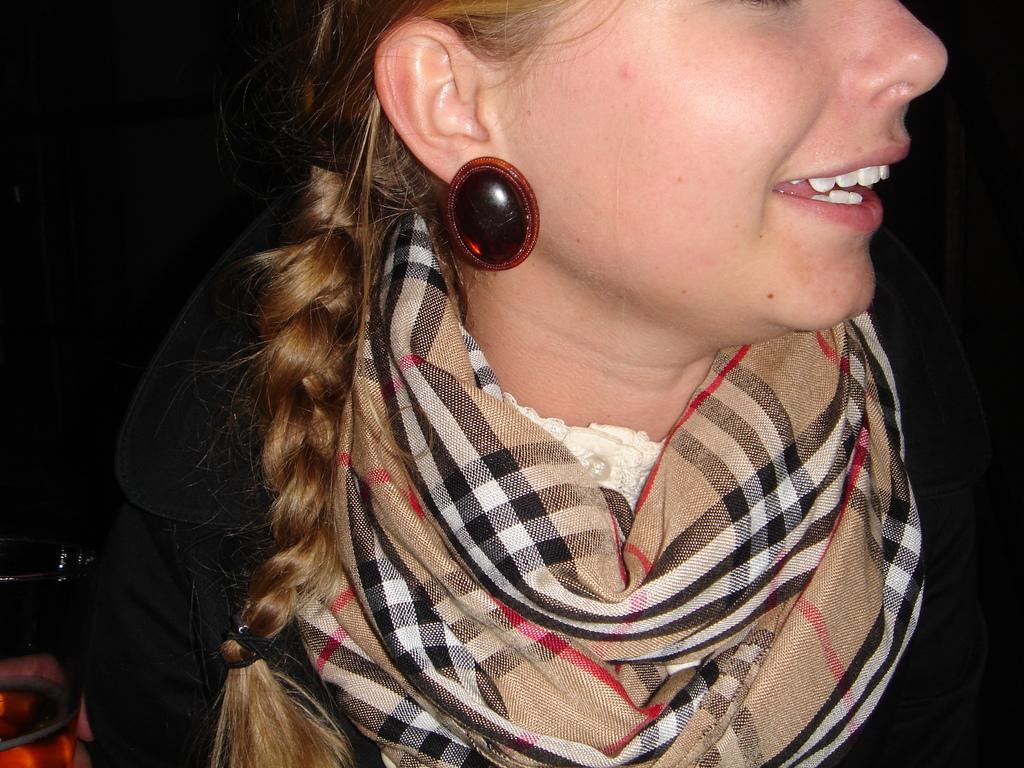Who or what is the main subject of the image? There is a person in the image. What is the person wearing around their neck? The person is wearing a cream and black color scarf. What color is the shirt the person is wearing? The person is wearing a black color shirt. Can you describe the background of the image? The background of the image is dark. What type of story does the person's lip tell in the image? There is no story being told by the person's lip in the image, as the focus is on the person's clothing and the dark background. 